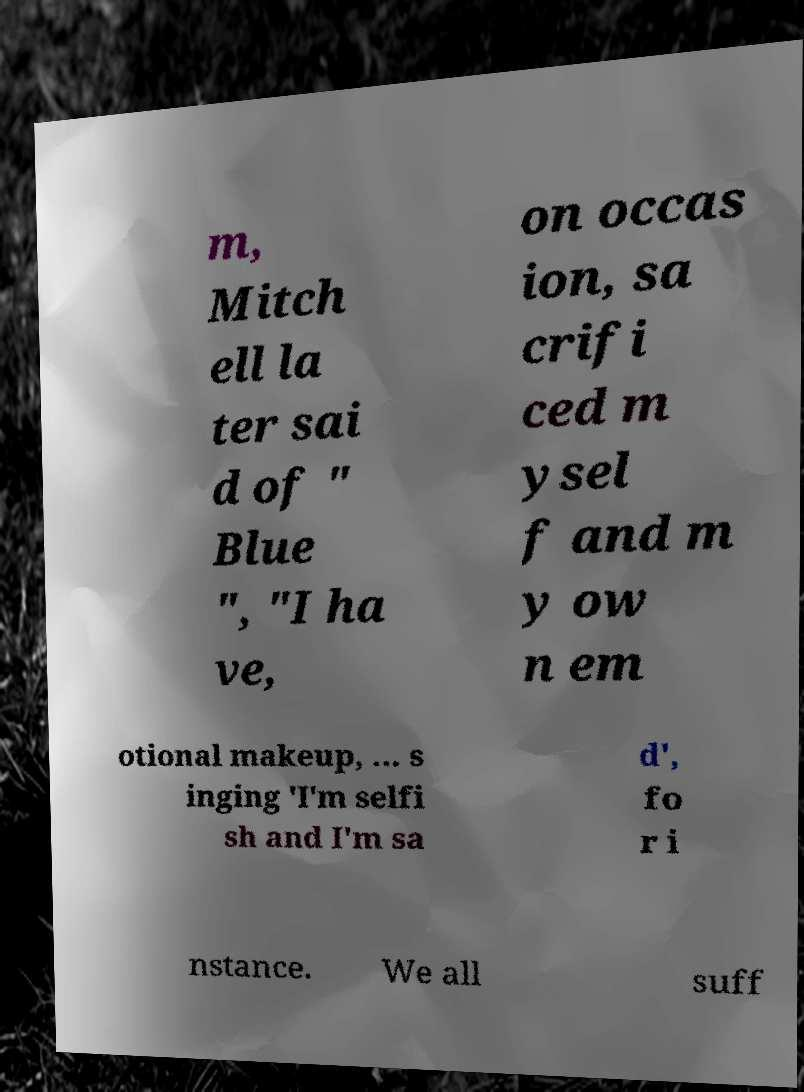I need the written content from this picture converted into text. Can you do that? m, Mitch ell la ter sai d of " Blue ", "I ha ve, on occas ion, sa crifi ced m ysel f and m y ow n em otional makeup, ... s inging 'I'm selfi sh and I'm sa d', fo r i nstance. We all suff 